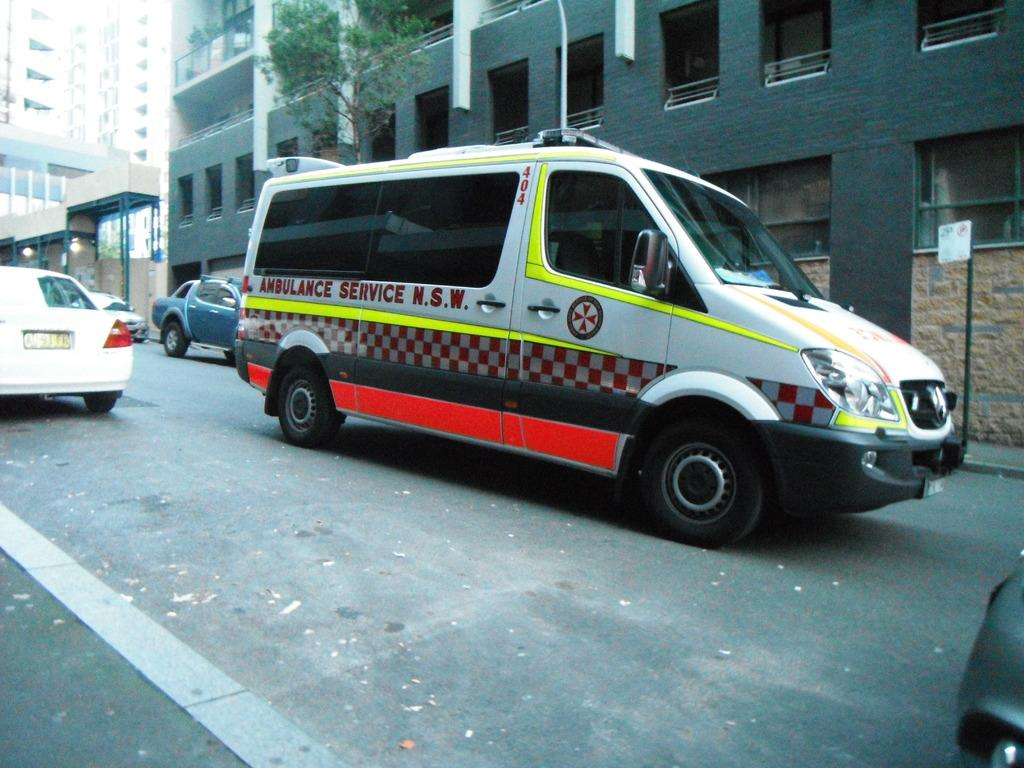<image>
Render a clear and concise summary of the photo. a gray and green van with ambulance services on the side of it. 